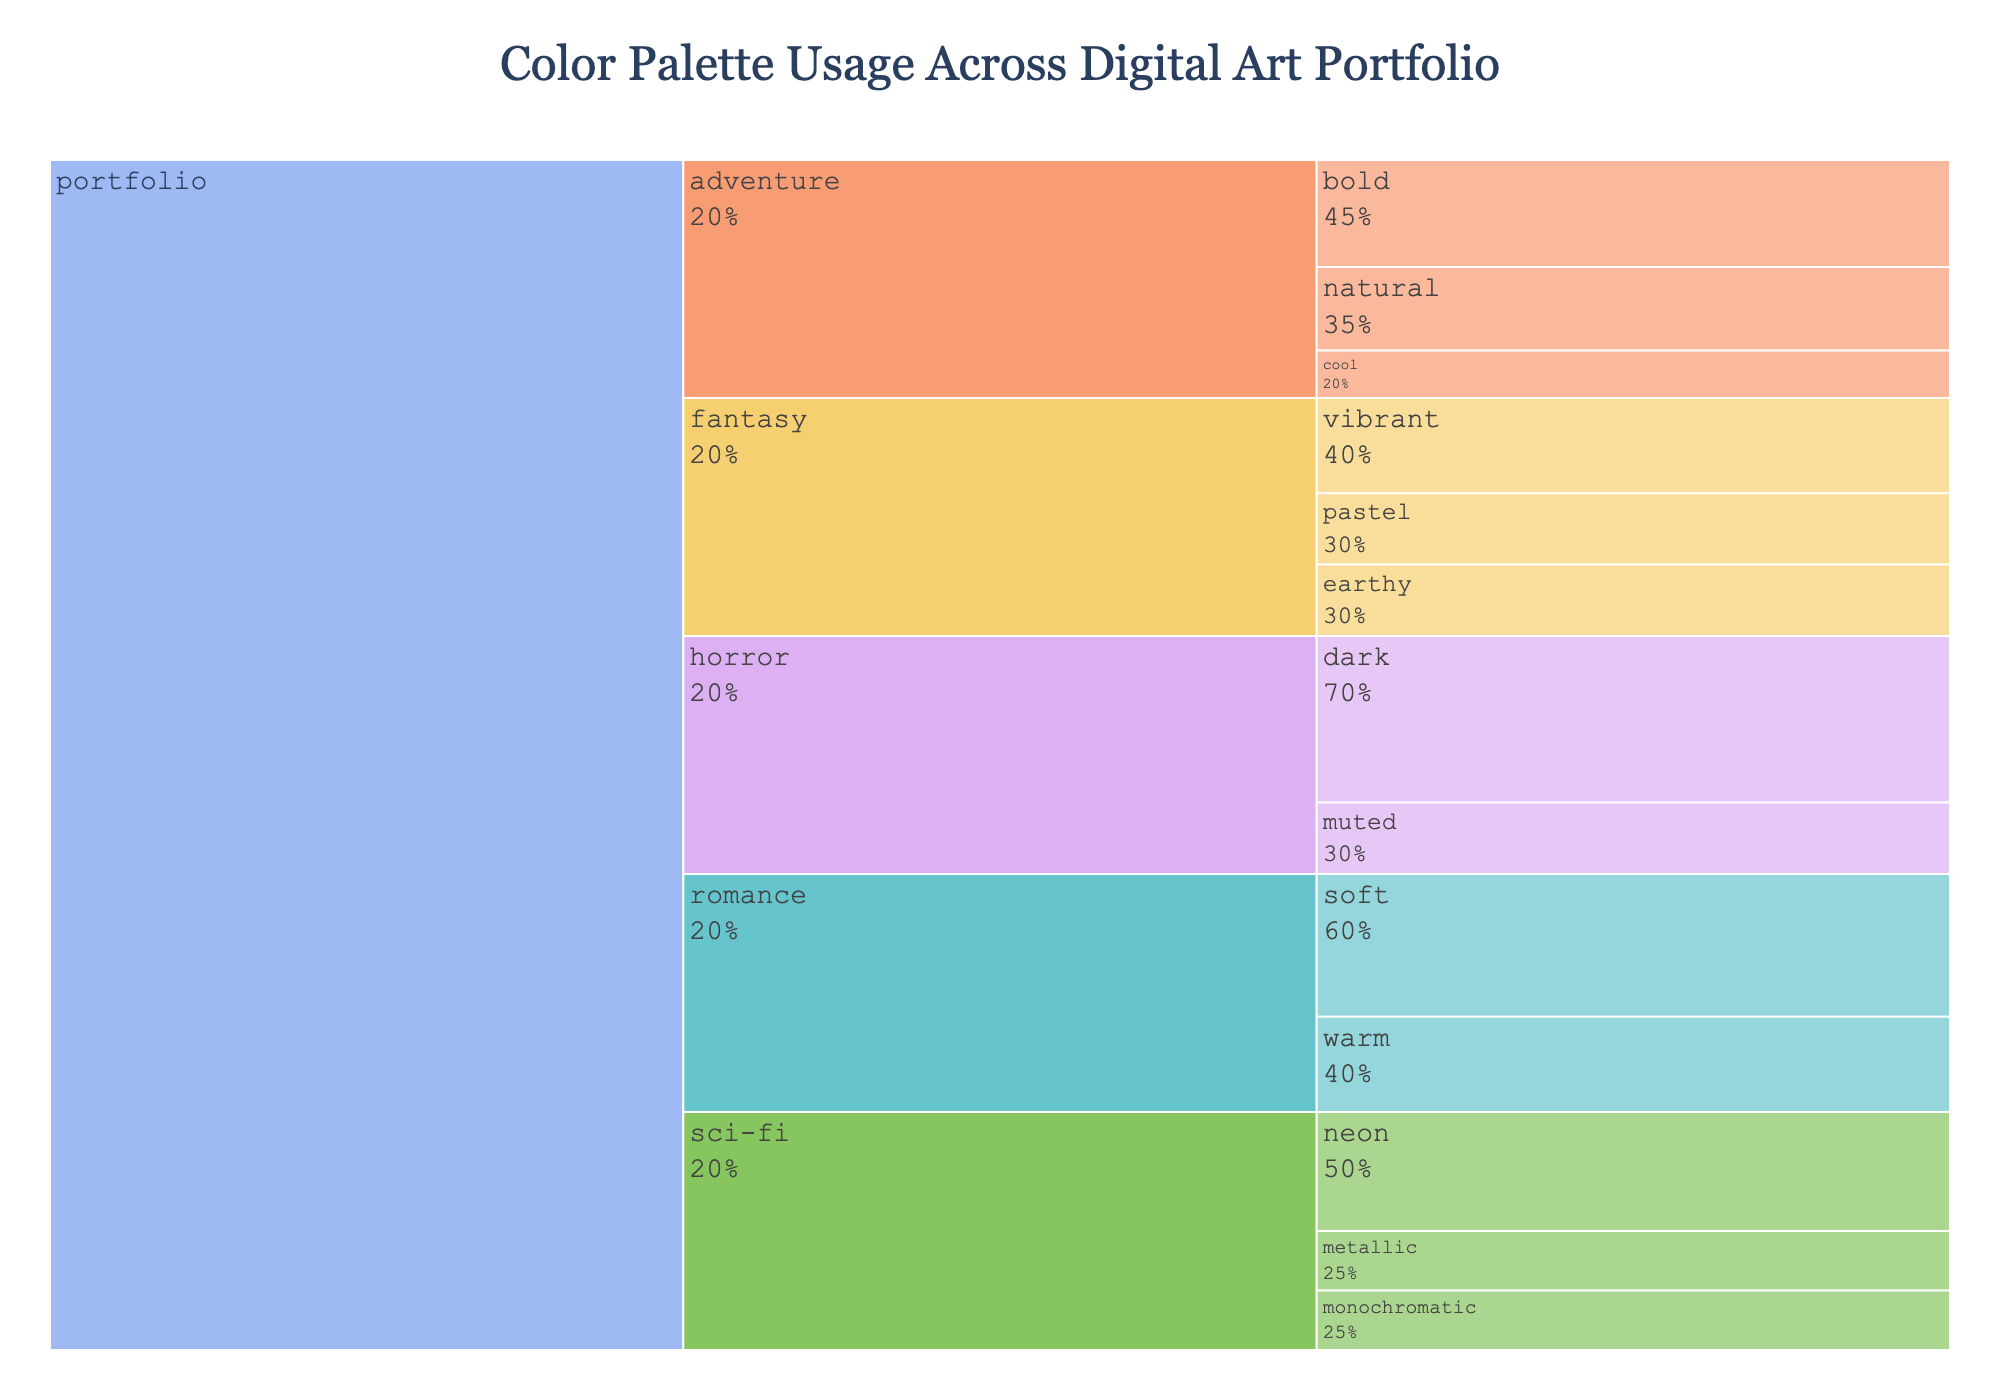what is the usage percentage of the vibrant color palette in fantasy? Locate the branch for the fantasy theme, within it, find the vibrant color palette and check its percentage usage.
Answer: 40% Which theme uses the dark color palette the most? Locate all themes, check the percentage usage for the dark color palette under each theme, and identify which theme has the highest percentage.
Answer: horror What is the total usage percentage of pastel and earthy color palettes in the fantasy theme? Find the usage percentages for pastel and earthy color palettes in the fantasy theme and sum them up: 30% (pastel) + 30% (earthy) = 60%.
Answer: 60% Which project theme has the least total usage of different color palettes combined? Sum the usage percentages of all color palettes within each theme and determine which theme has the lowest total.
Answer: horror What percentage of sci-fi theme color palettes are either metallic or monochromatic? Add the usage percentages for metallic and monochromatic under the sci-fi theme: 25% (metallic) + 25% (monochromatic) = 50%.
Answer: 50% How does the proportion of soft color usage in the romance theme compare to the vibrant color usage in the fantasy theme? Compare the usage percentage of soft color in the romance theme (60%) with the vibrant color in the fantasy theme (40%).
Answer: romance soft 60%, fantasy vibrant 40% What percentage of the adventure theme is the bold color palette? Identify the usage percentage of the bold color palette under the adventure theme.
Answer: 45% Which theme has the most diverse color palette usage? Count the number of different color palettes under each theme and identify which one has the most.
Answer: adventure What is the average usage percentage of color palettes in the sci-fi theme? Sum the usage percentages of all color palettes in the sci-fi theme: 50% (neon) + 25% (monochromatic) + 25% (metallic) = 100%. Divide by the number of palettes (3): 100% / 3 ≈ 33.33%.
Answer: 33.33% How does the usage of warm colors in the romance theme compare with cool colors in the adventure theme? Compare the usage percentage of warm colors in romance theme (40%) with cool colors in adventure theme (20%).
Answer: romance warm 40%, adventure cool 20% 